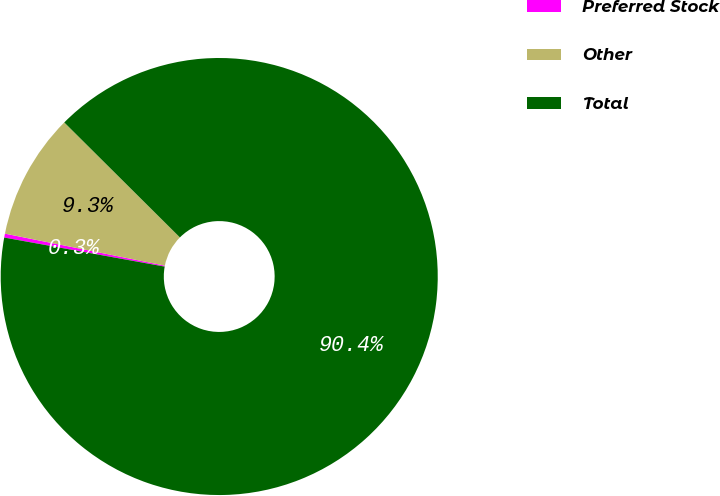<chart> <loc_0><loc_0><loc_500><loc_500><pie_chart><fcel>Preferred Stock<fcel>Other<fcel>Total<nl><fcel>0.29%<fcel>9.31%<fcel>90.4%<nl></chart> 